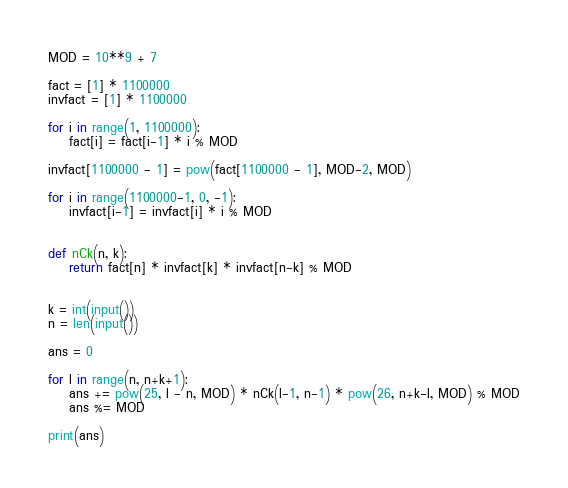Convert code to text. <code><loc_0><loc_0><loc_500><loc_500><_Python_>MOD = 10**9 + 7

fact = [1] * 1100000
invfact = [1] * 1100000

for i in range(1, 1100000):
    fact[i] = fact[i-1] * i % MOD

invfact[1100000 - 1] = pow(fact[1100000 - 1], MOD-2, MOD)

for i in range(1100000-1, 0, -1):
    invfact[i-1] = invfact[i] * i % MOD


def nCk(n, k):
    return fact[n] * invfact[k] * invfact[n-k] % MOD


k = int(input())
n = len(input())

ans = 0

for l in range(n, n+k+1):
    ans += pow(25, l - n, MOD) * nCk(l-1, n-1) * pow(26, n+k-l, MOD) % MOD
    ans %= MOD

print(ans)</code> 